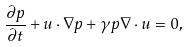Convert formula to latex. <formula><loc_0><loc_0><loc_500><loc_500>\frac { \partial p } { \partial t } + { u } \cdot \nabla p + \gamma p \nabla \cdot { u } = 0 ,</formula> 